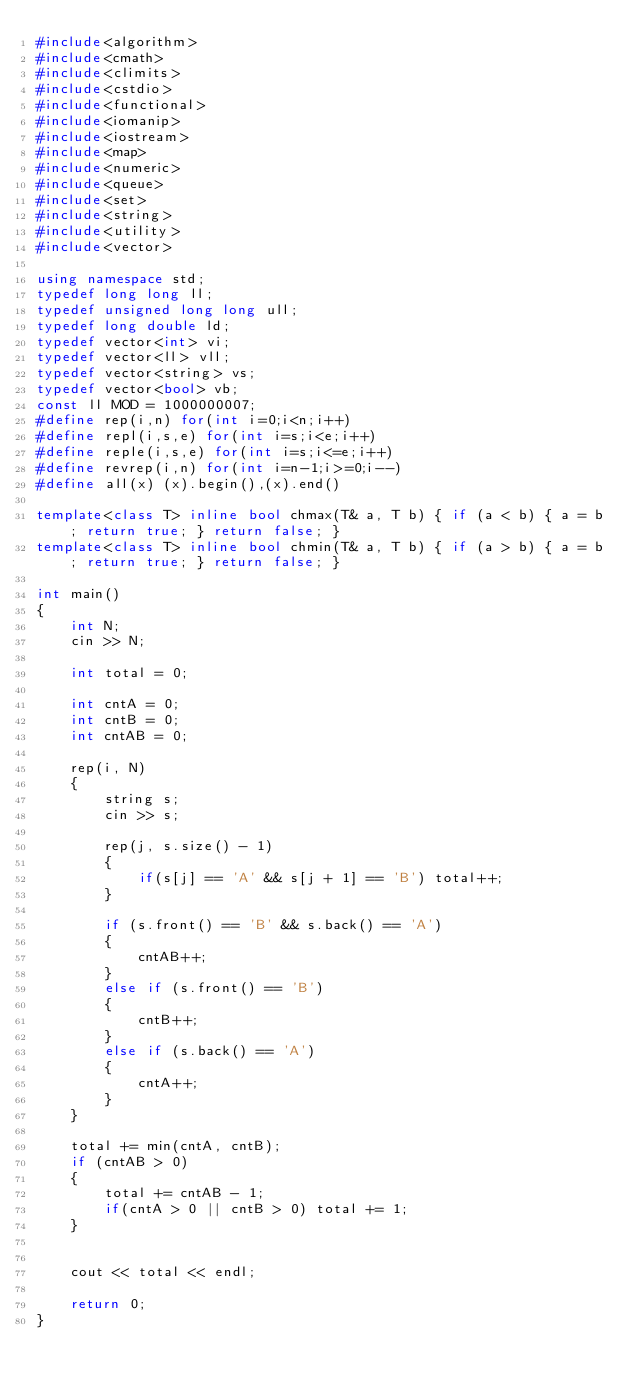<code> <loc_0><loc_0><loc_500><loc_500><_C++_>#include<algorithm>
#include<cmath>
#include<climits>
#include<cstdio>
#include<functional>
#include<iomanip>
#include<iostream>
#include<map>
#include<numeric>
#include<queue>
#include<set>
#include<string>
#include<utility>
#include<vector>

using namespace std;
typedef long long ll;
typedef unsigned long long ull;
typedef long double ld;
typedef vector<int> vi;
typedef vector<ll> vll;
typedef vector<string> vs;
typedef vector<bool> vb;
const ll MOD = 1000000007;
#define rep(i,n) for(int i=0;i<n;i++)
#define repl(i,s,e) for(int i=s;i<e;i++)
#define reple(i,s,e) for(int i=s;i<=e;i++)
#define revrep(i,n) for(int i=n-1;i>=0;i--)
#define all(x) (x).begin(),(x).end()

template<class T> inline bool chmax(T& a, T b) { if (a < b) { a = b; return true; } return false; }
template<class T> inline bool chmin(T& a, T b) { if (a > b) { a = b; return true; } return false; }

int main()
{
	int N;
	cin >> N;

	int total = 0;

	int cntA = 0;
	int cntB = 0;
	int cntAB = 0;

	rep(i, N)
	{
		string s;
		cin >> s;

		rep(j, s.size() - 1)
		{
			if(s[j] == 'A' && s[j + 1] == 'B') total++;
		}

		if (s.front() == 'B' && s.back() == 'A')
		{
			cntAB++;
		}
		else if (s.front() == 'B')
		{
			cntB++;
		}
		else if (s.back() == 'A')
		{
			cntA++;
		}
	}

	total += min(cntA, cntB);
	if (cntAB > 0)
	{
		total += cntAB - 1;
		if(cntA > 0 || cntB > 0) total += 1;
	}
	

	cout << total << endl;

	return 0;
}</code> 